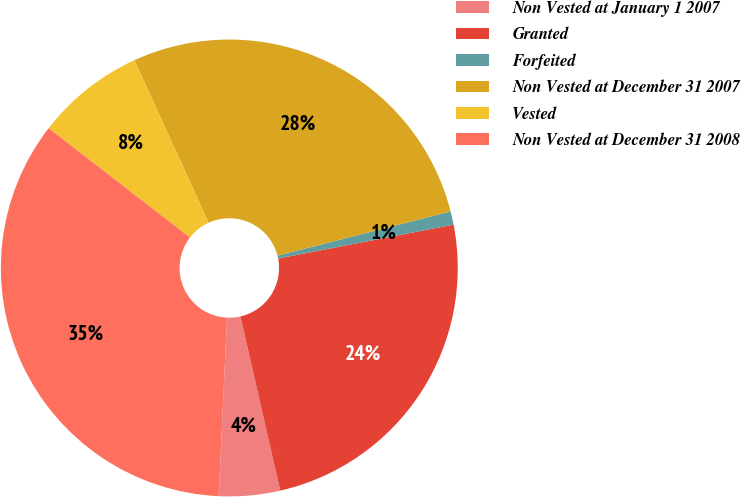Convert chart. <chart><loc_0><loc_0><loc_500><loc_500><pie_chart><fcel>Non Vested at January 1 2007<fcel>Granted<fcel>Forfeited<fcel>Non Vested at December 31 2007<fcel>Vested<fcel>Non Vested at December 31 2008<nl><fcel>4.32%<fcel>24.46%<fcel>0.94%<fcel>27.84%<fcel>7.7%<fcel>34.74%<nl></chart> 